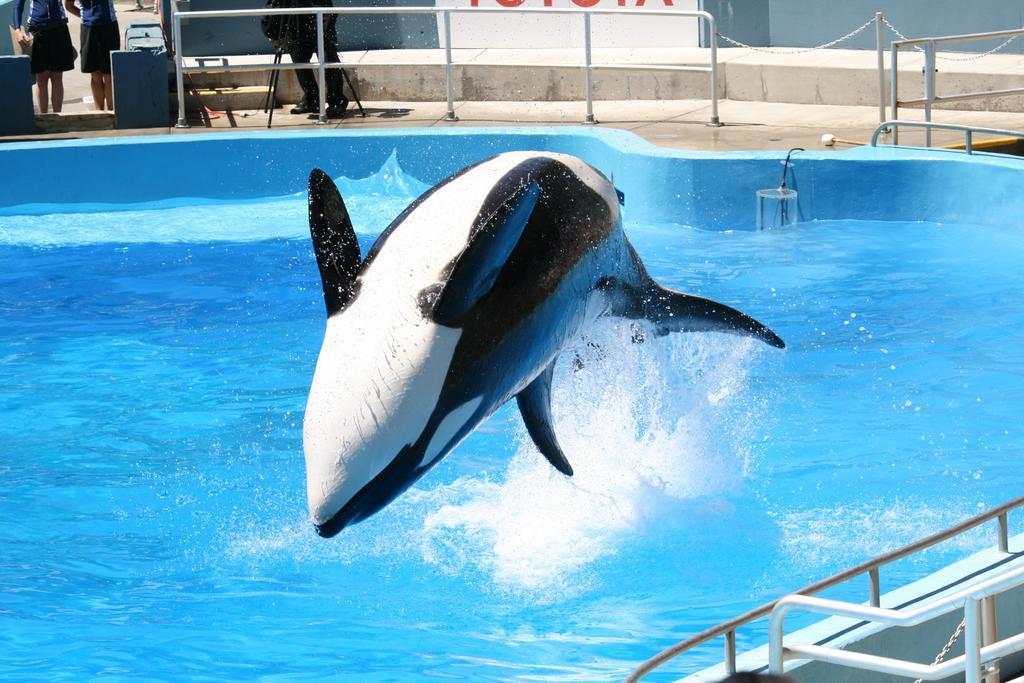Could you give a brief overview of what you see in this image? In the center of the image we can see a dolphin. In the background of the image we can see a pool which contains water and barricades, rods. At the top of the image we can see some people, stand, wall. 